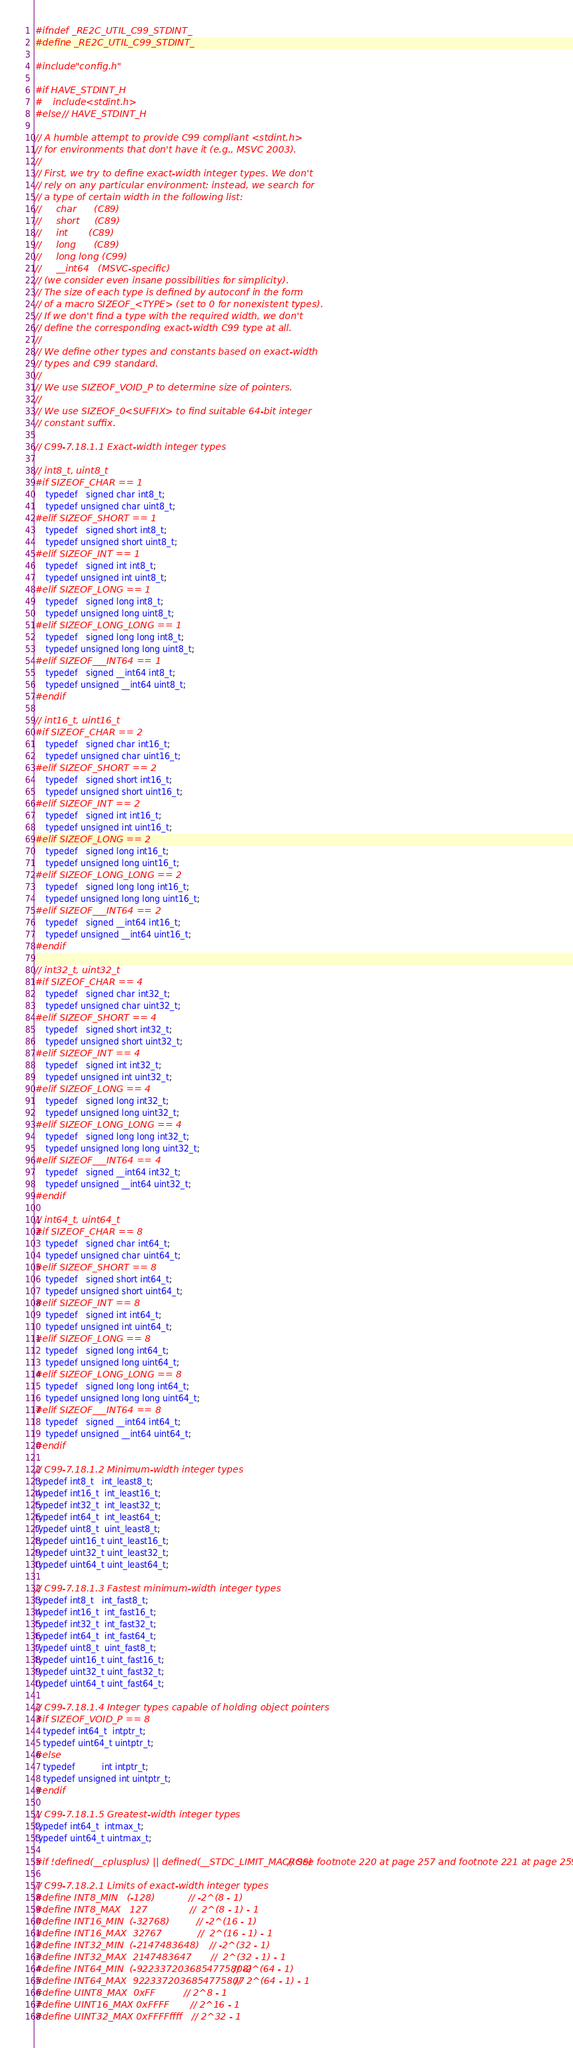Convert code to text. <code><loc_0><loc_0><loc_500><loc_500><_C_>#ifndef _RE2C_UTIL_C99_STDINT_
#define _RE2C_UTIL_C99_STDINT_

#include "config.h"

#if HAVE_STDINT_H
#    include <stdint.h>
#else // HAVE_STDINT_H

// A humble attempt to provide C99 compliant <stdint.h>
// for environments that don't have it (e.g., MSVC 2003).
//
// First, we try to define exact-width integer types. We don't
// rely on any particular environment: instead, we search for
// a type of certain width in the following list:
//     char      (C89)
//     short     (C89)
//     int       (C89)
//     long      (C89)
//     long long (C99)
//     __int64   (MSVC-specific)
// (we consider even insane possibilities for simplicity).
// The size of each type is defined by autoconf in the form
// of a macro SIZEOF_<TYPE> (set to 0 for nonexistent types).
// If we don't find a type with the required width, we don't
// define the corresponding exact-width C99 type at all.
//
// We define other types and constants based on exact-width
// types and C99 standard.
//
// We use SIZEOF_VOID_P to determine size of pointers.
//
// We use SIZEOF_0<SUFFIX> to find suitable 64-bit integer
// constant suffix.

// C99-7.18.1.1 Exact-width integer types

// int8_t, uint8_t
#if SIZEOF_CHAR == 1
    typedef   signed char int8_t;
    typedef unsigned char uint8_t;
#elif SIZEOF_SHORT == 1
    typedef   signed short int8_t;
    typedef unsigned short uint8_t;
#elif SIZEOF_INT == 1
    typedef   signed int int8_t;
    typedef unsigned int uint8_t;
#elif SIZEOF_LONG == 1
    typedef   signed long int8_t;
    typedef unsigned long uint8_t;
#elif SIZEOF_LONG_LONG == 1
    typedef   signed long long int8_t;
    typedef unsigned long long uint8_t;
#elif SIZEOF___INT64 == 1
    typedef   signed __int64 int8_t;
    typedef unsigned __int64 uint8_t;
#endif

// int16_t, uint16_t
#if SIZEOF_CHAR == 2
    typedef   signed char int16_t;
    typedef unsigned char uint16_t;
#elif SIZEOF_SHORT == 2
    typedef   signed short int16_t;
    typedef unsigned short uint16_t;
#elif SIZEOF_INT == 2
    typedef   signed int int16_t;
    typedef unsigned int uint16_t;
#elif SIZEOF_LONG == 2
    typedef   signed long int16_t;
    typedef unsigned long uint16_t;
#elif SIZEOF_LONG_LONG == 2
    typedef   signed long long int16_t;
    typedef unsigned long long uint16_t;
#elif SIZEOF___INT64 == 2
    typedef   signed __int64 int16_t;
    typedef unsigned __int64 uint16_t;
#endif

// int32_t, uint32_t
#if SIZEOF_CHAR == 4
    typedef   signed char int32_t;
    typedef unsigned char uint32_t;
#elif SIZEOF_SHORT == 4
    typedef   signed short int32_t;
    typedef unsigned short uint32_t;
#elif SIZEOF_INT == 4
    typedef   signed int int32_t;
    typedef unsigned int uint32_t;
#elif SIZEOF_LONG == 4
    typedef   signed long int32_t;
    typedef unsigned long uint32_t;
#elif SIZEOF_LONG_LONG == 4
    typedef   signed long long int32_t;
    typedef unsigned long long uint32_t;
#elif SIZEOF___INT64 == 4
    typedef   signed __int64 int32_t;
    typedef unsigned __int64 uint32_t;
#endif

// int64_t, uint64_t
#if SIZEOF_CHAR == 8
    typedef   signed char int64_t;
    typedef unsigned char uint64_t;
#elif SIZEOF_SHORT == 8
    typedef   signed short int64_t;
    typedef unsigned short uint64_t;
#elif SIZEOF_INT == 8
    typedef   signed int int64_t;
    typedef unsigned int uint64_t;
#elif SIZEOF_LONG == 8
    typedef   signed long int64_t;
    typedef unsigned long uint64_t;
#elif SIZEOF_LONG_LONG == 8
    typedef   signed long long int64_t;
    typedef unsigned long long uint64_t;
#elif SIZEOF___INT64 == 8
    typedef   signed __int64 int64_t;
    typedef unsigned __int64 uint64_t;
#endif

// C99-7.18.1.2 Minimum-width integer types
typedef int8_t   int_least8_t;
typedef int16_t  int_least16_t;
typedef int32_t  int_least32_t;
typedef int64_t  int_least64_t;
typedef uint8_t  uint_least8_t;
typedef uint16_t uint_least16_t;
typedef uint32_t uint_least32_t;
typedef uint64_t uint_least64_t;

// C99-7.18.1.3 Fastest minimum-width integer types
typedef int8_t   int_fast8_t;
typedef int16_t  int_fast16_t;
typedef int32_t  int_fast32_t;
typedef int64_t  int_fast64_t;
typedef uint8_t  uint_fast8_t;
typedef uint16_t uint_fast16_t;
typedef uint32_t uint_fast32_t;
typedef uint64_t uint_fast64_t;

// C99-7.18.1.4 Integer types capable of holding object pointers
#if SIZEOF_VOID_P == 8
   typedef int64_t  intptr_t;
   typedef uint64_t uintptr_t;
#else
   typedef          int intptr_t;
   typedef unsigned int uintptr_t;
#endif

// C99-7.18.1.5 Greatest-width integer types
typedef int64_t  intmax_t;
typedef uint64_t uintmax_t;

#if !defined(__cplusplus) || defined(__STDC_LIMIT_MACROS) // See footnote 220 at page 257 and footnote 221 at page 259

// C99-7.18.2.1 Limits of exact-width integer types
#define INT8_MIN   (-128)                 // -2^(8 - 1)
#define INT8_MAX   127                    //  2^(8 - 1) - 1
#define INT16_MIN  (-32768)               // -2^(16 - 1)
#define INT16_MAX  32767                  //  2^(16 - 1) - 1
#define INT32_MIN  (-2147483648)          // -2^(32 - 1)
#define INT32_MAX  2147483647             //  2^(32 - 1) - 1
#define INT64_MIN  (-9223372036854775808) // -2^(64 - 1)
#define INT64_MAX  9223372036854775807    //  2^(64 - 1) - 1
#define UINT8_MAX  0xFF               // 2^8 - 1
#define UINT16_MAX 0xFFFF             // 2^16 - 1
#define UINT32_MAX 0xFFFFffff         // 2^32 - 1</code> 